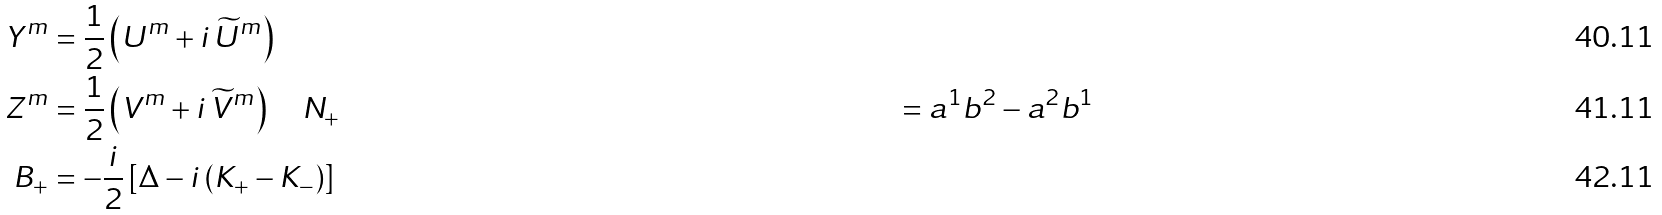Convert formula to latex. <formula><loc_0><loc_0><loc_500><loc_500>Y ^ { m } & = \frac { 1 } { 2 } \left ( U ^ { m } + i \, \widetilde { U } ^ { m } \right ) \\ Z ^ { m } & = \frac { 1 } { 2 } \left ( V ^ { m } + i \, \widetilde { V } ^ { m } \right ) \quad N _ { + } & = a ^ { 1 } b ^ { 2 } - a ^ { 2 } b ^ { 1 } \\ B _ { + } & = - \frac { i } { 2 } \left [ \Delta - i \left ( K _ { + } - K _ { - } \right ) \right ]</formula> 